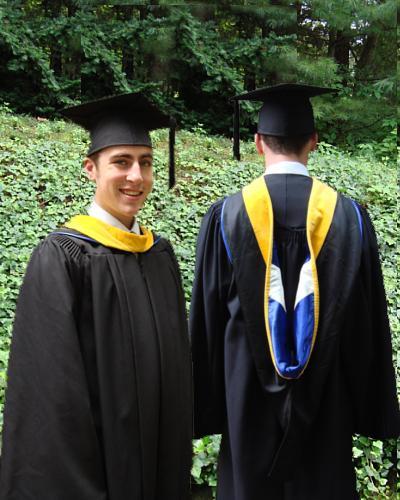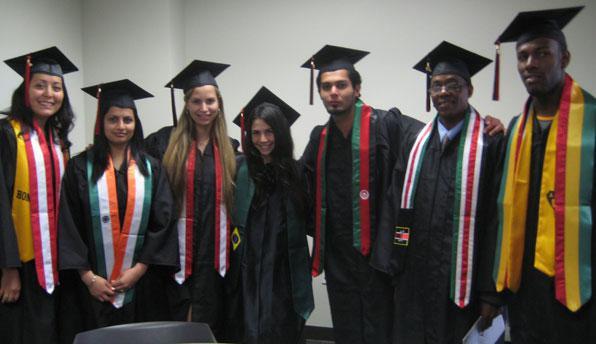The first image is the image on the left, the second image is the image on the right. For the images displayed, is the sentence "Some of the people's tassels on their hats are yellow." factually correct? Answer yes or no. No. The first image is the image on the left, the second image is the image on the right. Examine the images to the left and right. Is the description "There are at most two graduates in the left image." accurate? Answer yes or no. Yes. 